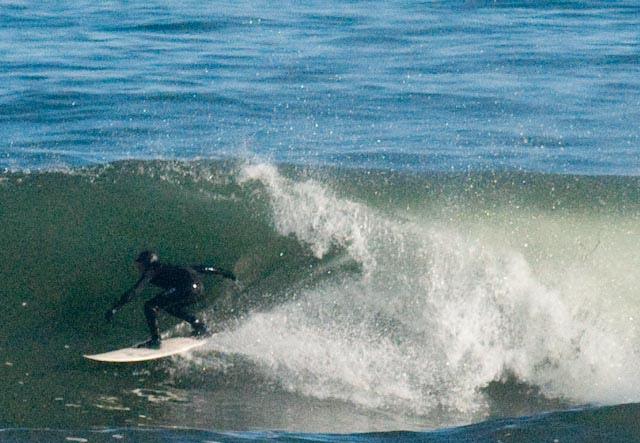What is the man wearing?
Be succinct. Wetsuit. What is the color of the wave?
Give a very brief answer. White. Is this a sunny or cloudy day?
Keep it brief. Sunny. What is the man riding?
Short answer required. Surfboard. 